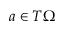Convert formula to latex. <formula><loc_0><loc_0><loc_500><loc_500>a \in T \Omega</formula> 